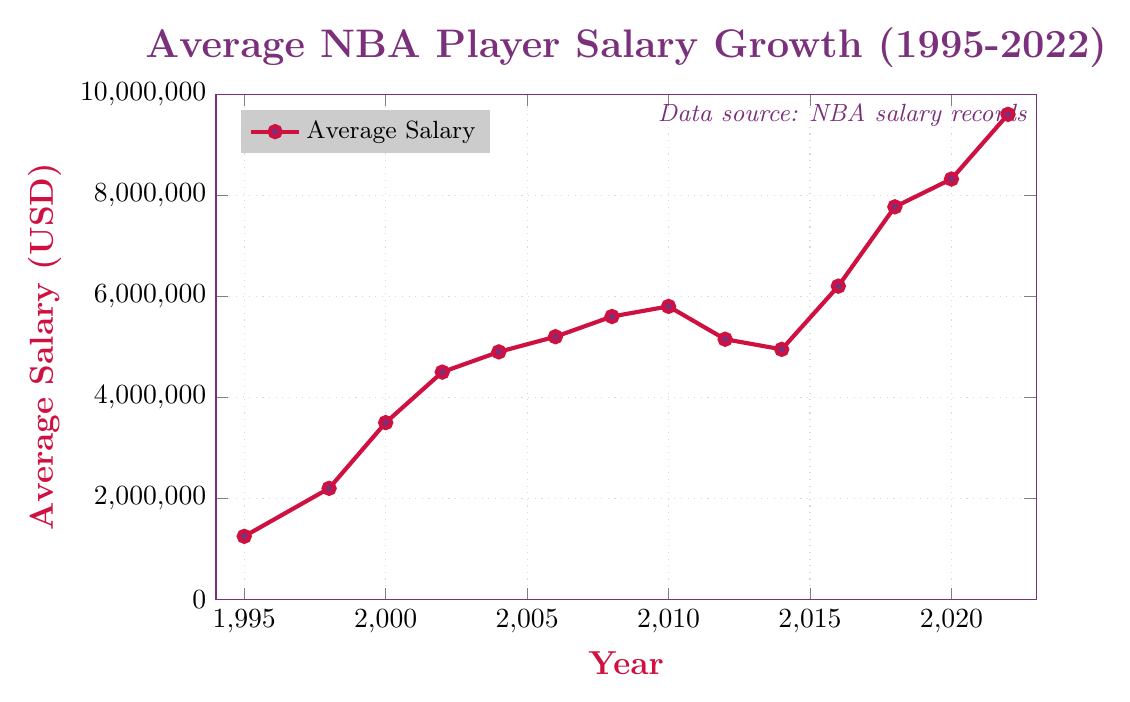How much did the average NBA salary increase from 1995 to 2022? First, locate the average NBA salary for the years 1995 and 2022 on the graph. In 1995, the salary is 1,250,000 USD, and in 2022, it is 9,600,000 USD. Subtract the 1995 value from the 2022 value: 9,600,000 - 1,250,000 = 8,350,000 USD.
Answer: 8,350,000 USD In which year did the average NBA salary first exceed 5 million USD? Identify the data points and observe the year-by-year values. Find the year where the salary first surpasses 5 million USD. It occurs in 2006, where the salary is 5,200,000 USD.
Answer: 2006 What is the percentage increase in the average NBA salary from 2000 to 2022? First, find the salaries for the years 2000 (3,500,000 USD) and 2022 (9,600,000 USD). Calculate the difference: 9,600,000 - 3,500,000 = 6,100,000. To find the percentage increase, divide the difference by the 2000 salary and multiply by 100: (6,100,000 / 3,500,000) * 100 ≈ 174.29%.
Answer: 174.29% Which years show a decrease in the average NBA salary compared to their previous years? Review the plot to identify years where the salary drops from the previous year. Salaries decrease in 2012 (5,150,000 USD from 2010's 5,800,000 USD) and in 2014 (4,950,000 USD from 2012's 5,150,000 USD).
Answer: 2012, 2014 Between which consecutive years is the largest increase in the average NBA salary observed? Visually inspect and calculate the differences between consecutive years' values from the plot. The largest increase is between 2016 and 2018: 7,770,000 - 6,200,000 = 1,570,000 USD.
Answer: 2016 to 2018 How does the growth in the average NBA salary from 1995 to 1998 compare to the growth from 2004 to 2006? First, determine the changes: From 1995 to 1998: 2,200,000 - 1,250,000 = 950,000 USD and from 2004 to 2006: 5,200,000 - 4,900,000 = 300,000 USD. Comparison shows that the growth from 1995 to 1998 (950,000 USD) is greater than from 2004 to 2006 (300,000 USD).
Answer: Greater from 1995 to 1998 By what factor did the average NBA salary change from 1995 to 2022? Identify the salaries for 1995 (1,250,000 USD) and 2022 (9,600,000 USD). Divide the 2022 salary by the 1995 salary: 9,600,000 / 1,250,000 = 7.68.
Answer: 7.68 In which year was the first decline in the average NBA salary observed after the year 2000? Observe the trend post-2000 and identify the first decline. The salary first declines in 2012 (5,150,000 USD from 2010's 5,800,000 USD).
Answer: 2012 What is the average salary for the data points from 1995 to 2002? Sum the salary values for the years 1995, 1998, 2000, and 2002 (1,250,000 + 2,200,000 + 3,500,000 + 4,500,000 = 11,450,000). Divide by 4, as there are 4 data points: 11,450,000 / 4 = 2,862,500 USD.
Answer: 2,862,500 USD 